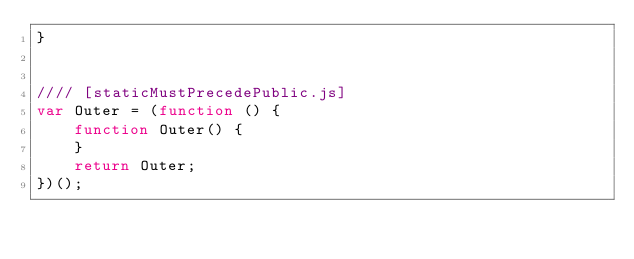Convert code to text. <code><loc_0><loc_0><loc_500><loc_500><_JavaScript_>}


//// [staticMustPrecedePublic.js]
var Outer = (function () {
    function Outer() {
    }
    return Outer;
})();
</code> 